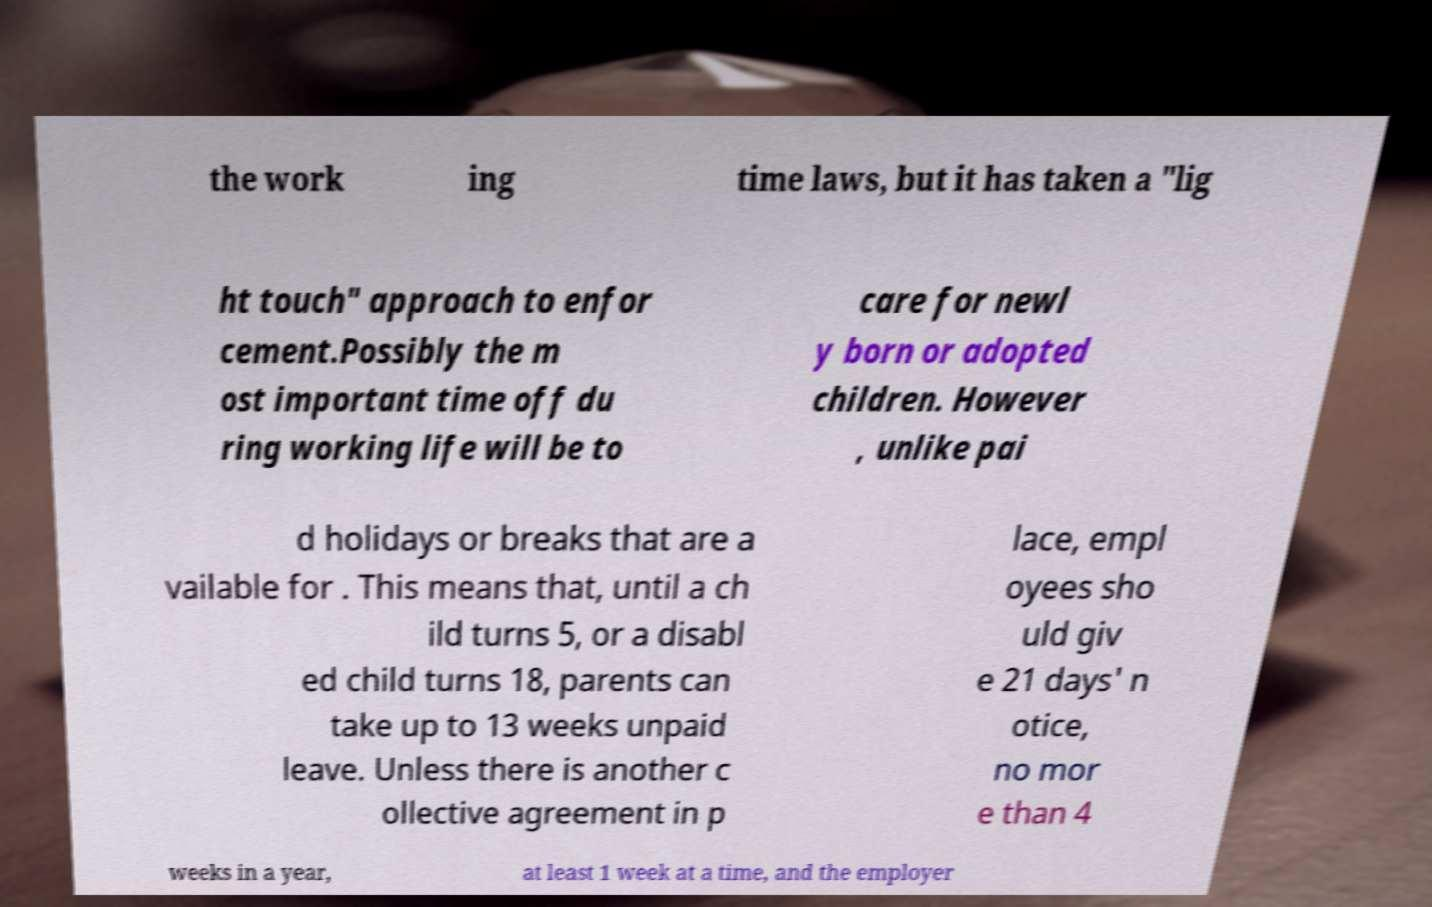What messages or text are displayed in this image? I need them in a readable, typed format. the work ing time laws, but it has taken a "lig ht touch" approach to enfor cement.Possibly the m ost important time off du ring working life will be to care for newl y born or adopted children. However , unlike pai d holidays or breaks that are a vailable for . This means that, until a ch ild turns 5, or a disabl ed child turns 18, parents can take up to 13 weeks unpaid leave. Unless there is another c ollective agreement in p lace, empl oyees sho uld giv e 21 days' n otice, no mor e than 4 weeks in a year, at least 1 week at a time, and the employer 